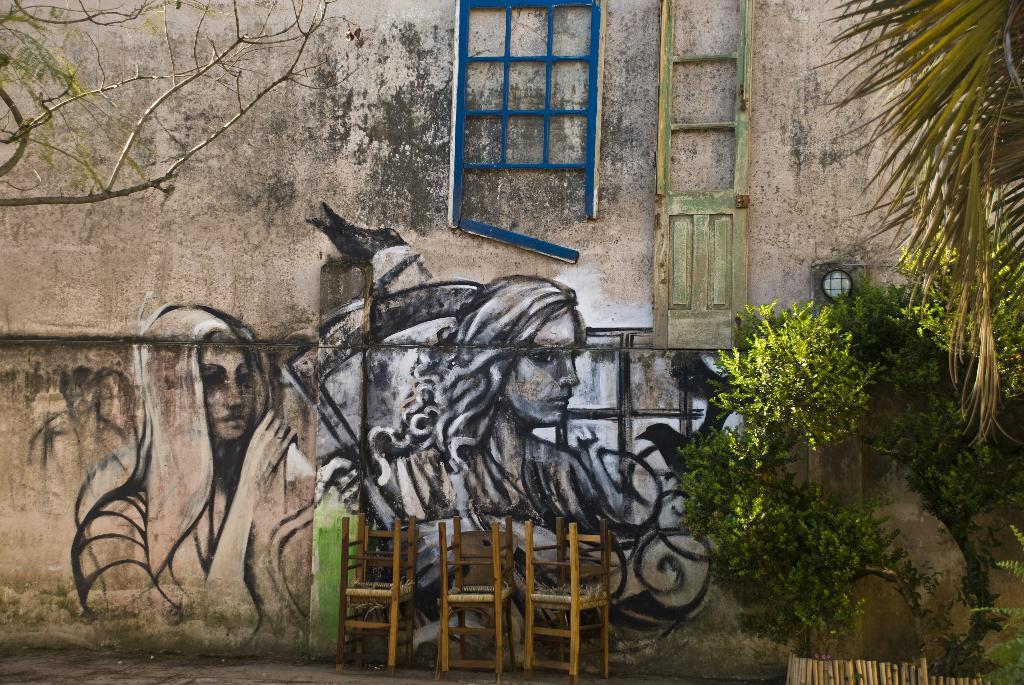What is the main subject of the image? The main subject of the image is a part of a building wall. What is on the wall in the image? There is a painting on the wall in the image. What can be seen beside the wall in the image? There is a part of a tree visible beside the wall in the image. How many snails are crawling on the painting in the image? There are no snails visible in the image; the painting is the only subject on the wall. 